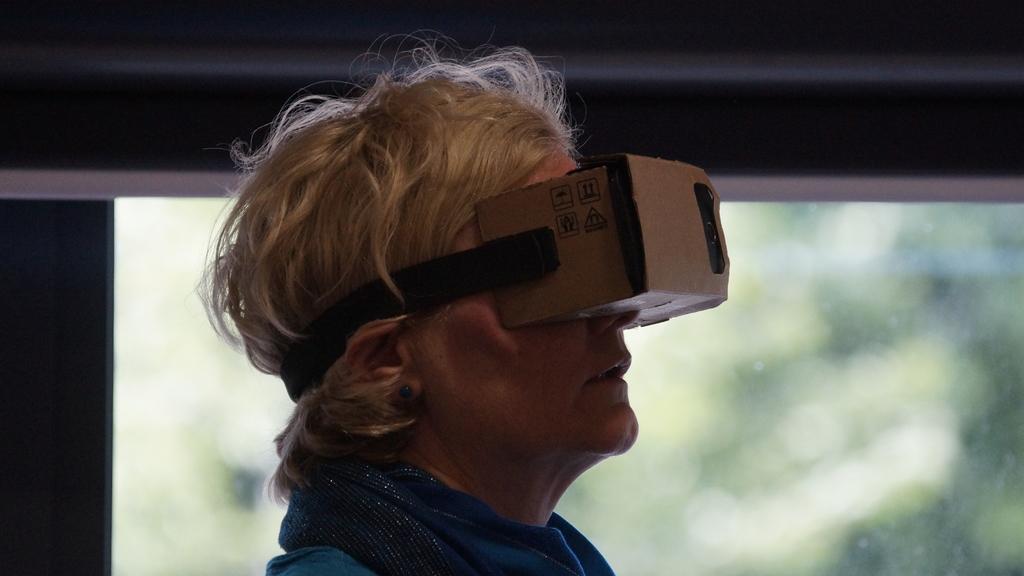Describe this image in one or two sentences. In this image, we can see a person wearing clothes and VR glass. In the background, image is blurred. 